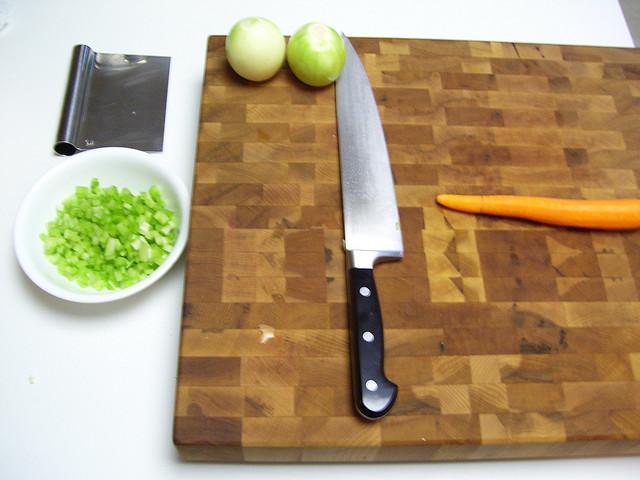How many vegetables can be seen on the cutting board?
Give a very brief answer. 3. How many stalks of celery are there?
Give a very brief answer. 0. How many apples are visible?
Give a very brief answer. 2. How many people are laying down?
Give a very brief answer. 0. 